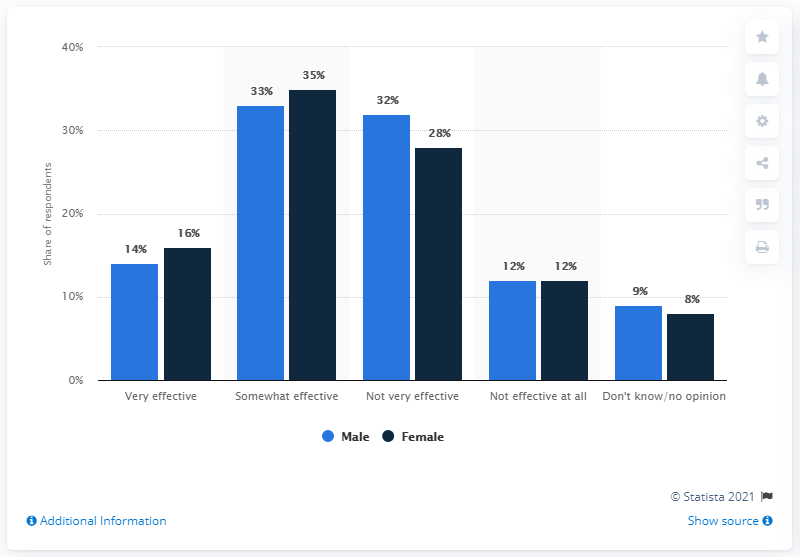Point out several critical features in this image. For a female adult, a face mask is an effective means of preventing the spread of the coronavirus. 